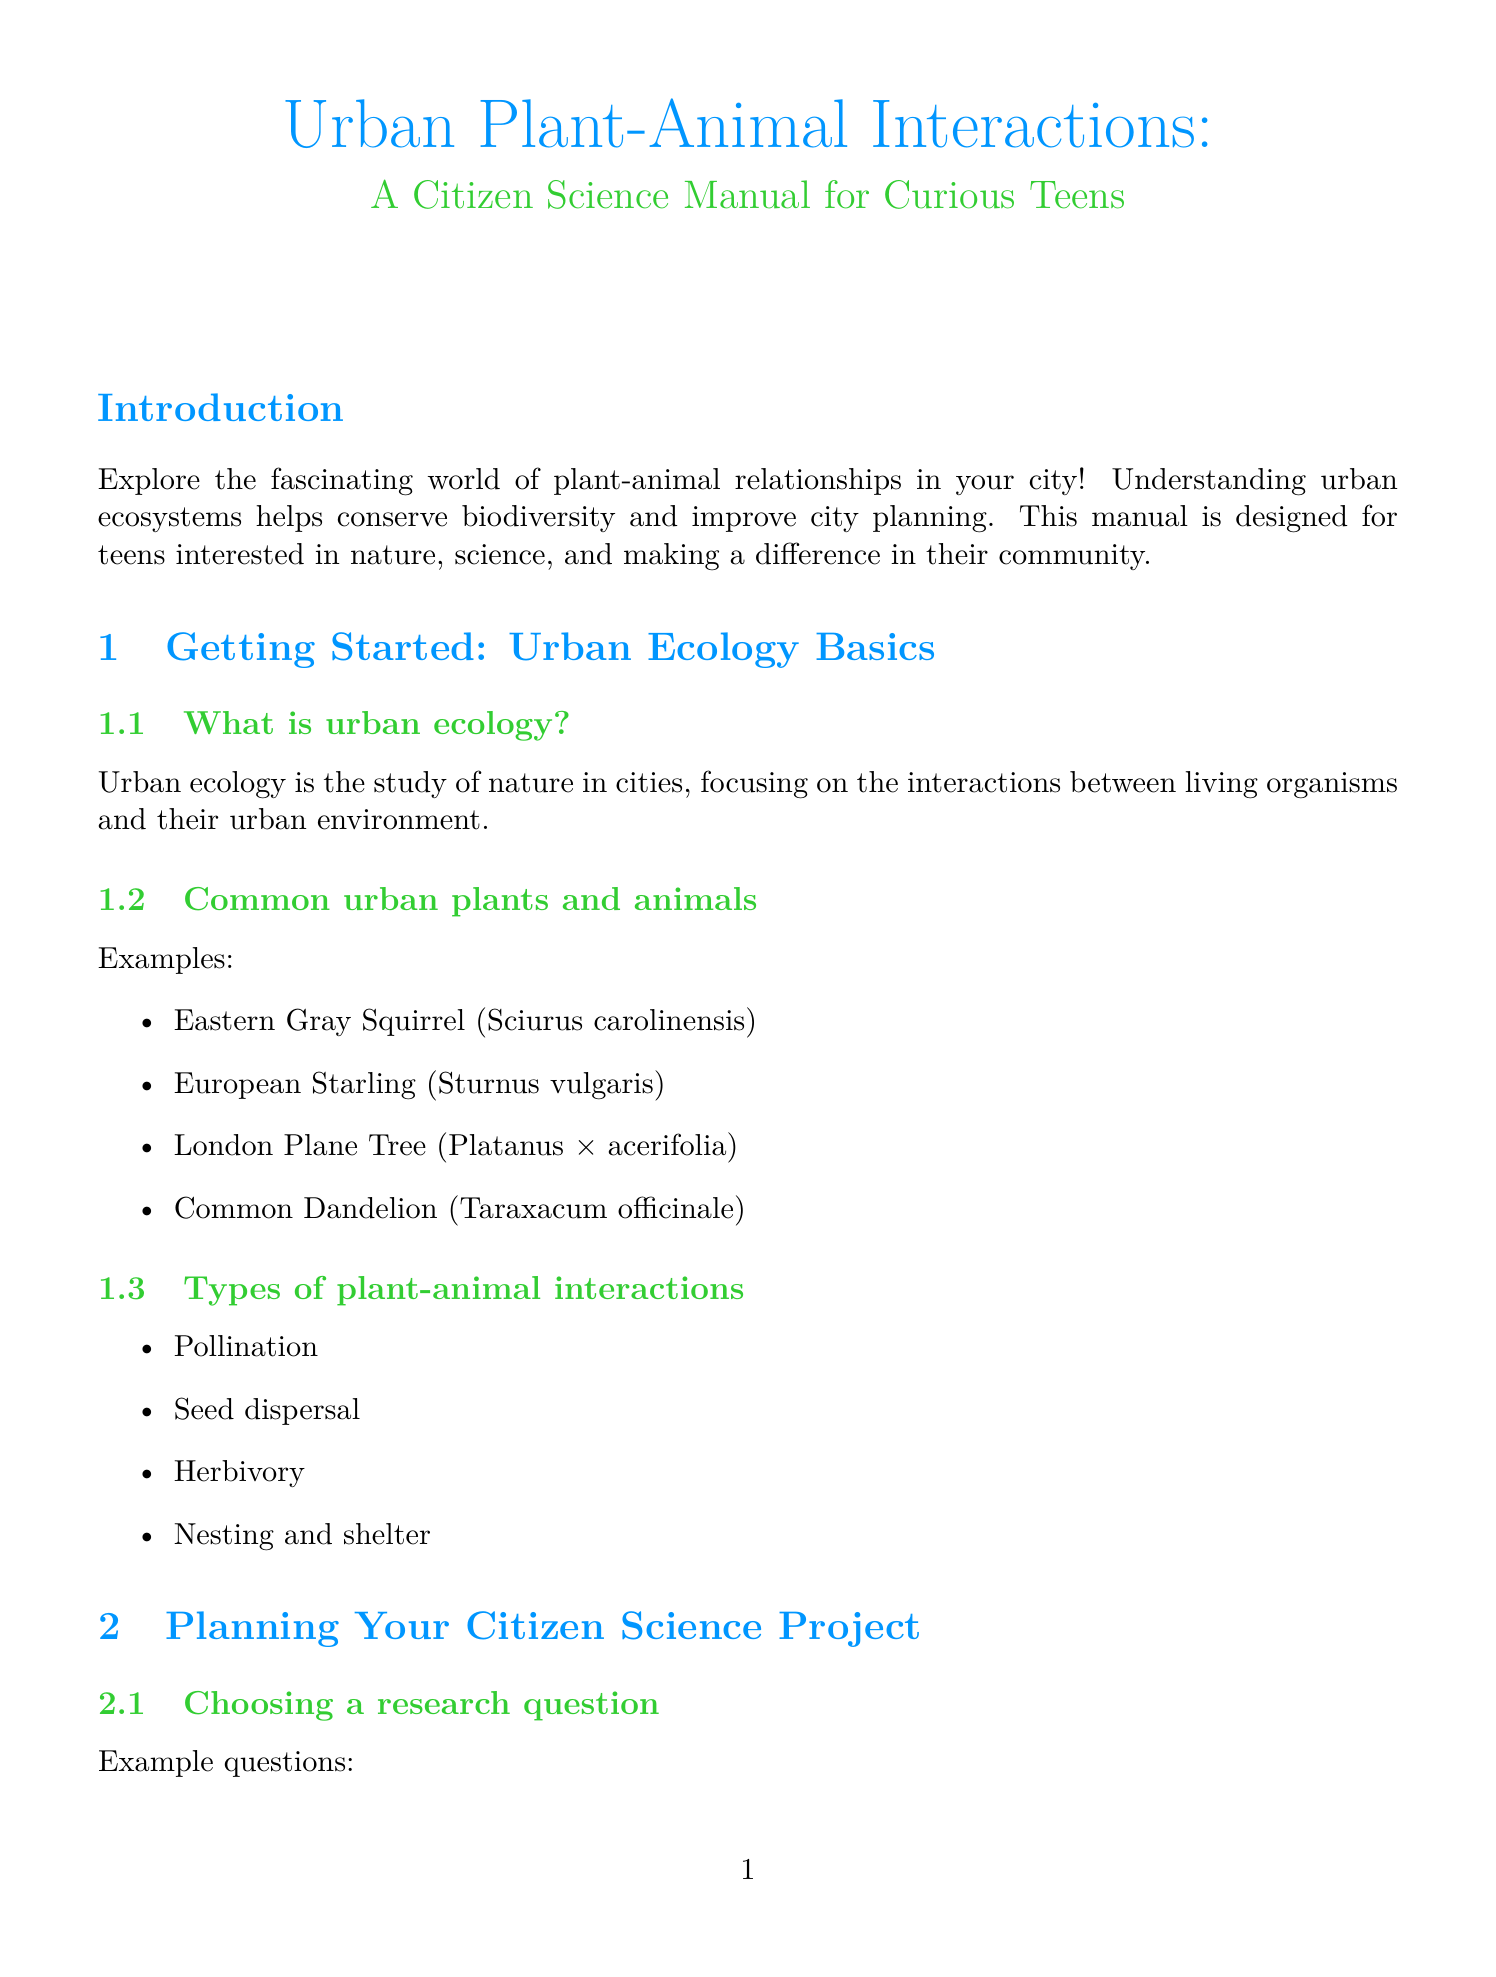What is the title of the manual? The title of the manual is found at the beginning of the document and is "Urban Plant-Animal Interactions: A Citizen Science Manual for Curious Teens."
Answer: Urban Plant-Animal Interactions: A Citizen Science Manual for Curious Teens Who is the target audience for this manual? The target audience is mentioned in the introduction section, which indicates that the manual is designed for "Teens interested in nature, science, and making a difference in their community."
Answer: Teens interested in nature, science, and making a difference in their community What is one example of an urban animal listed in the document? One example of an urban animal can be found in Chapter 1, where it lists common urban plants and animals.
Answer: Eastern Gray Squirrel How many types of plant-animal interactions are mentioned? The document specifies the number of types of interactions in Chapter 1, under the section about types of plant-animal interactions.
Answer: Four What is the first step in creating a project timeline? The first step in creating a timeline is listed in Chapter 2, which details the steps for planning a citizen science project.
Answer: Define objectives Name one mobile app listed in the resources section. The mobile apps section under resources details several options available for use.
Answer: Seek by iNaturalist Which statistical concept is mentioned in the data analysis section? One of the statistical concepts outlined in Chapter 4 concerns basic statistical concepts relevant to data interpretation.
Answer: Mean What type of visual representation is suggested for data analysis? The document outlines various graph types that can be used for visual representation in Chapter 4.
Answer: Bar graphs What is one way to share findings mentioned in the document? The document includes multiple ways to share findings, which are highlighted in Chapter 5.
Answer: Creating a project report 